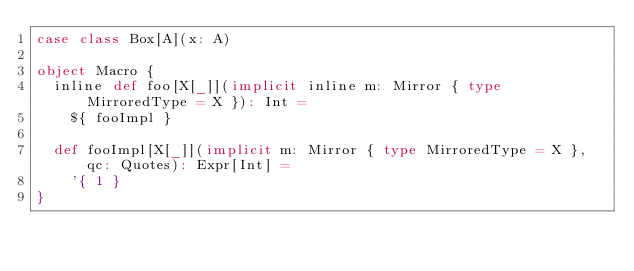<code> <loc_0><loc_0><loc_500><loc_500><_Scala_>case class Box[A](x: A)

object Macro {
  inline def foo[X[_]](implicit inline m: Mirror { type MirroredType = X }): Int =
    ${ fooImpl }

  def fooImpl[X[_]](implicit m: Mirror { type MirroredType = X }, qc: Quotes): Expr[Int] =
    '{ 1 }
}
</code> 